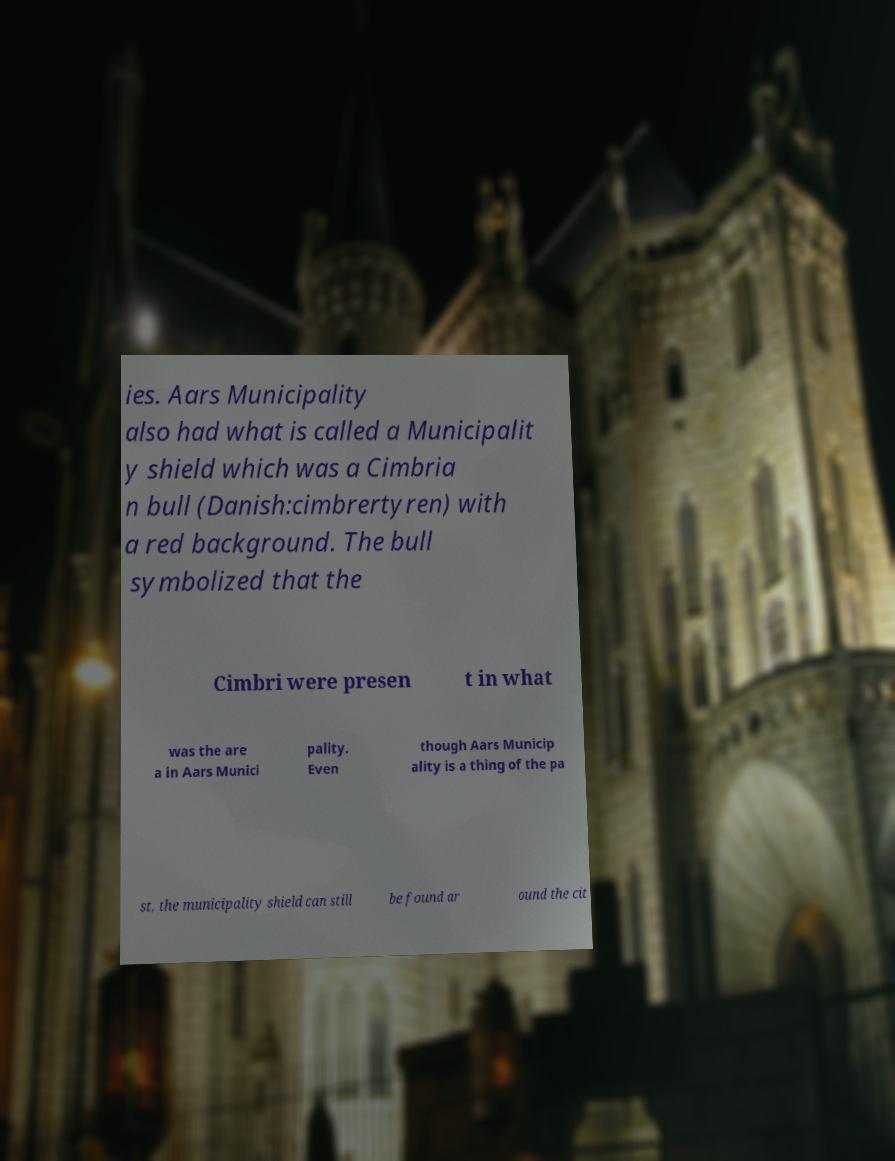There's text embedded in this image that I need extracted. Can you transcribe it verbatim? ies. Aars Municipality also had what is called a Municipalit y shield which was a Cimbria n bull (Danish:cimbrertyren) with a red background. The bull symbolized that the Cimbri were presen t in what was the are a in Aars Munici pality. Even though Aars Municip ality is a thing of the pa st, the municipality shield can still be found ar ound the cit 